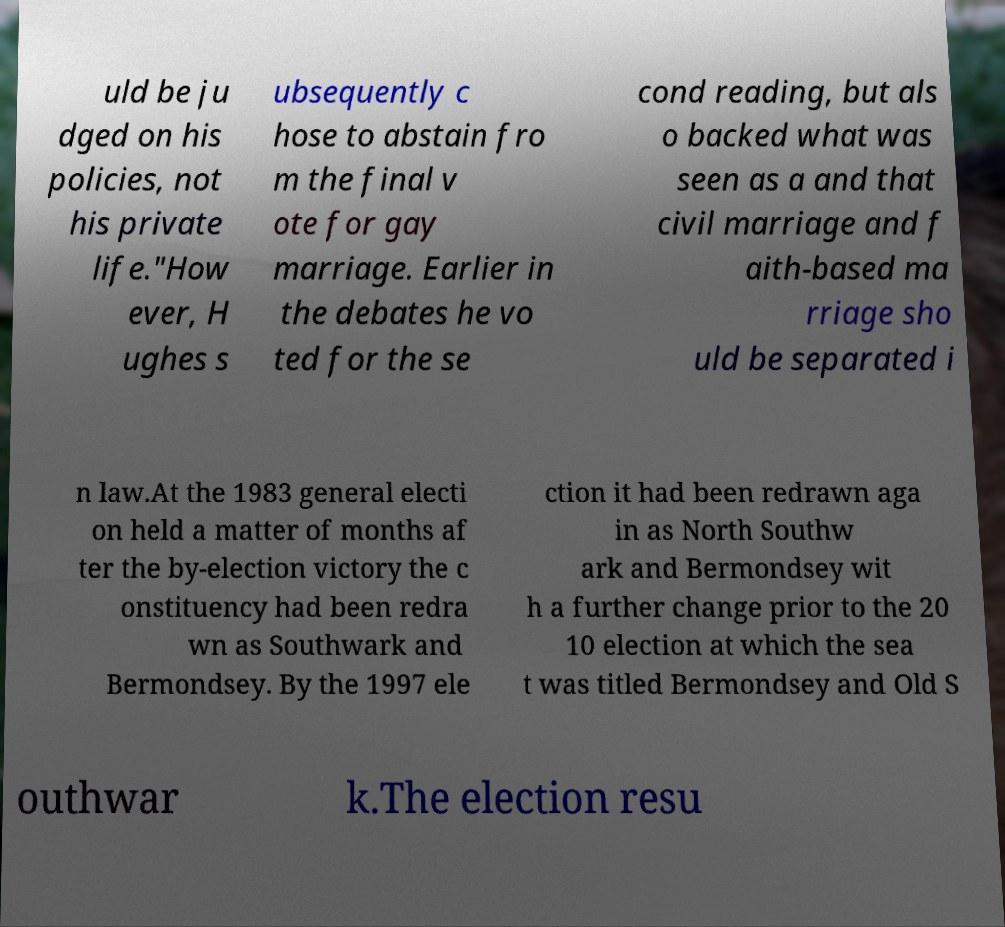Could you assist in decoding the text presented in this image and type it out clearly? uld be ju dged on his policies, not his private life."How ever, H ughes s ubsequently c hose to abstain fro m the final v ote for gay marriage. Earlier in the debates he vo ted for the se cond reading, but als o backed what was seen as a and that civil marriage and f aith-based ma rriage sho uld be separated i n law.At the 1983 general electi on held a matter of months af ter the by-election victory the c onstituency had been redra wn as Southwark and Bermondsey. By the 1997 ele ction it had been redrawn aga in as North Southw ark and Bermondsey wit h a further change prior to the 20 10 election at which the sea t was titled Bermondsey and Old S outhwar k.The election resu 